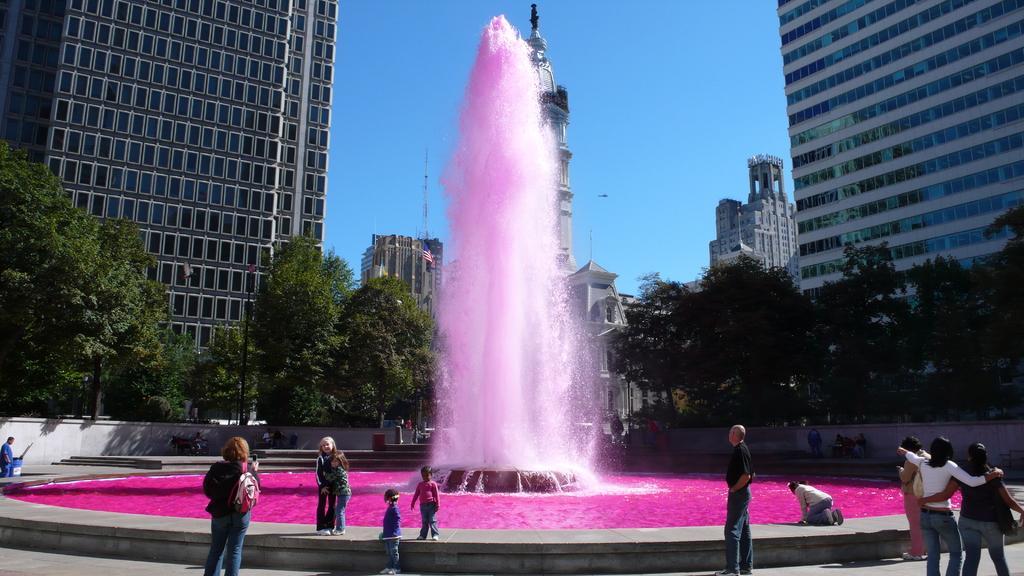In one or two sentences, can you explain what this image depicts? There is a pink colour fountain in the picture. The water is completely in pink colour. There are some children in front of the fountain. And there is a woman holding a bag in front of the children taking their picture. There is a man in front of the fountain looking at the water. There are two members who are looking at the fountain. Around the fountain there are some trees. Behind the trees there are buildings. And in the background we can observe a sky. 